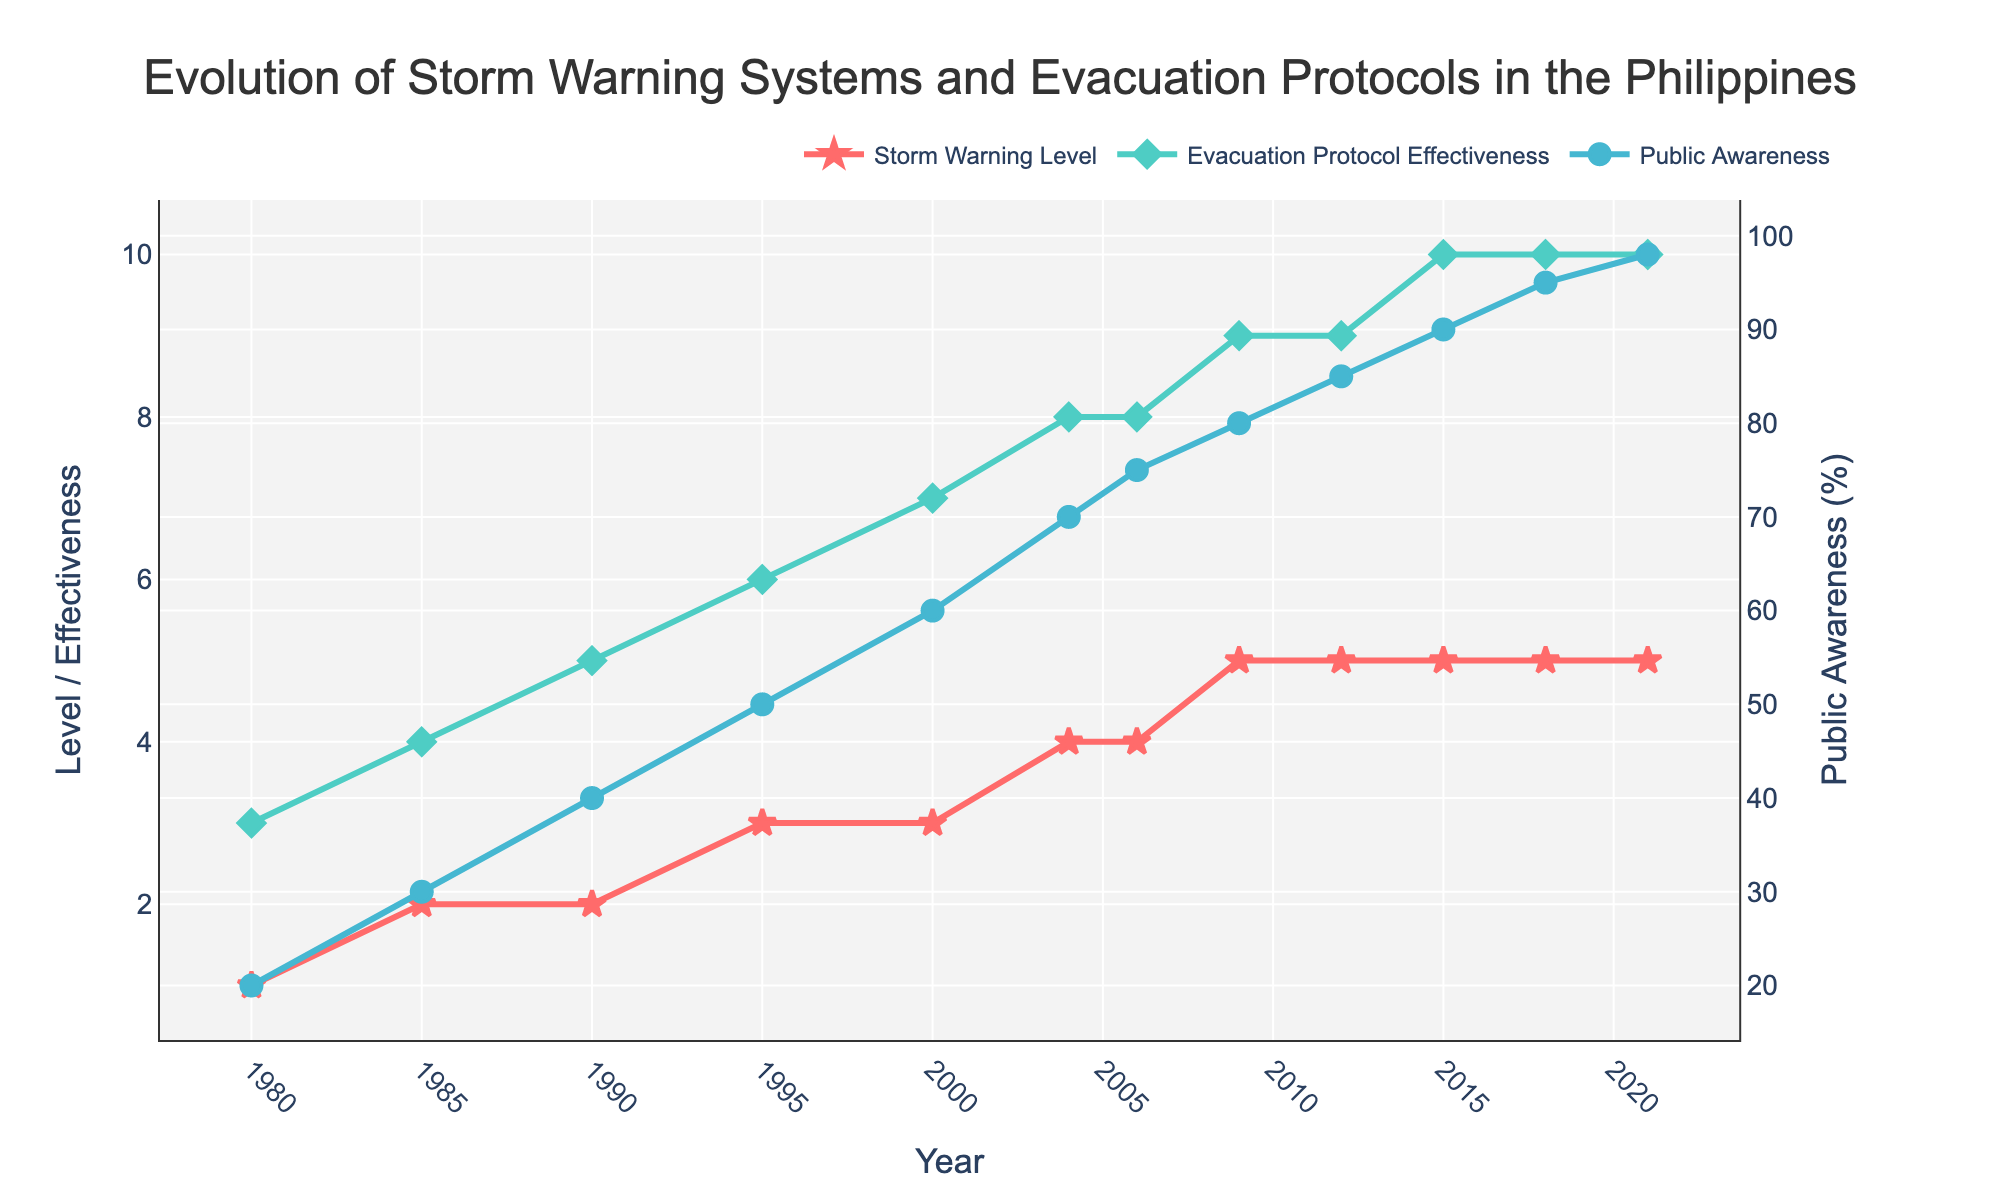What was the Storm Warning Level in 1995? The chart shows the Storm Warning Levels across the years from 1980 to 2021. Finding 1995 on the x-axis and checking the corresponding value on the Storm Warning Level line (the red line) will give the correct level.
Answer: 3 What is the difference in Public Awareness between 2000 and 2015? To determine the difference, find the value of Public Awareness in 2000 and 2015 on the chart (the blue line). Public Awareness is 60% in 2000 and 90% in 2015. Calculate the difference: 90% - 60% = 30%.
Answer: 30% Between which years did the Evacuation Protocol Effectiveness increase the most? Identify the green line indicating Evacuation Protocol Effectiveness across the years. Observe where the largest vertical leap occurs. The biggest increase is from 1995 (Effectiveness of 6) to 2000 (Effectiveness of 7), which is an increase of 1, repeated between increments 3, 4, and 9. Thus several steps have the maximum increase.
Answer: 1995 and 2000 (among others) What is the color of the line representing Storm Warning Level? The line in the chart representing Storm Warning Level can be identified by its color. The red line indicates Storm Warning Level.
Answer: Red How did Public Awareness (%) change from 1980 to 2021? To determine the change, observe the trend of the Public Awareness line (blue line) from 1980 to 2021. It starts at 20% in 1980 and continuously increases to 98% by 2021.
Answer: Increased by 78% What is the average Evacuation Protocol Effectiveness between 1980 and 2021? List the effectiveness values for each year: (3, 4, 5, 6, 7, 8, 8, 9, 9, 10, 10, 10). Summing these gives 89. The average would be 89 / 12 ≈ 7.42
Answer: 7.42 Which year had the highest Public Awareness, and what was the percentage? Determine the peak of the blue line (Public Awareness) on the chart. The highest point is in 2021, where Public Awareness reached 98%.
Answer: 2021, 98% Compare the Storm Warning Level in 1980 and 2021. How much did it change? Find the Storm Warning Levels for 1980 and 2021 on the red line. They are 1 and 5, respectively. Calculate the change: 5 - 1 = 4.
Answer: Increased by 4 In what year did the Evacuation Protocol Effectiveness reach maximum value, and what was it? Find the year when the green line for Evacuation Protocol Effectiveness hits its peak value. It reaches this peak in 2015 with a value of 10.
Answer: 2015, 10 Which parameter shows the greatest improvement over the years? Compare the improvement in Storm Warning Levels, Evacuation Protocol Effectiveness, and Public Awareness by tracing their trajectories from start to end. Public Awareness increased from 20% to 98% (a difference of 78%), which is the greatest numerical increase.
Answer: Public Awareness 